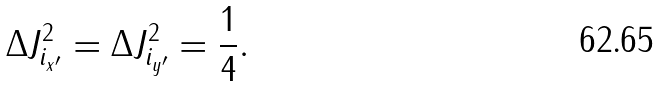Convert formula to latex. <formula><loc_0><loc_0><loc_500><loc_500>\Delta J _ { i _ { x ^ { \prime } } } ^ { 2 } = \Delta J _ { i _ { y ^ { \prime } } } ^ { 2 } = \frac { 1 } { 4 } .</formula> 